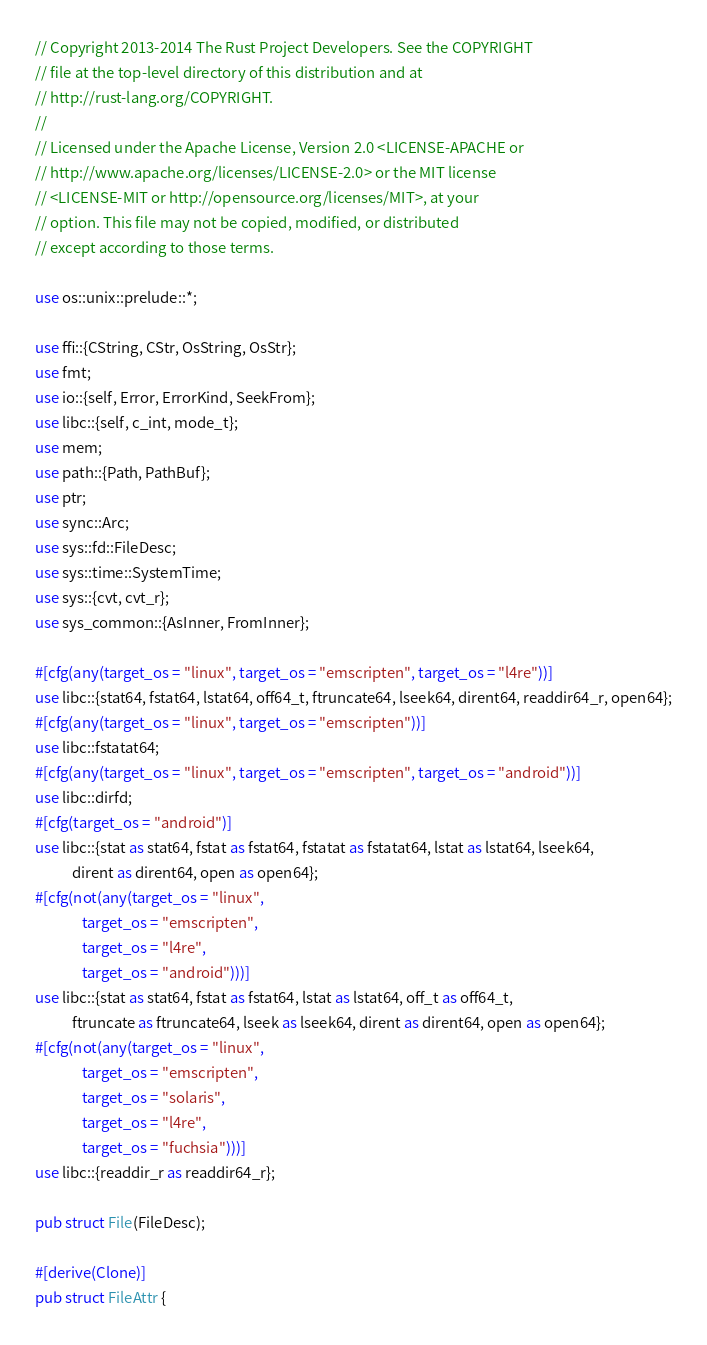<code> <loc_0><loc_0><loc_500><loc_500><_Rust_>// Copyright 2013-2014 The Rust Project Developers. See the COPYRIGHT
// file at the top-level directory of this distribution and at
// http://rust-lang.org/COPYRIGHT.
//
// Licensed under the Apache License, Version 2.0 <LICENSE-APACHE or
// http://www.apache.org/licenses/LICENSE-2.0> or the MIT license
// <LICENSE-MIT or http://opensource.org/licenses/MIT>, at your
// option. This file may not be copied, modified, or distributed
// except according to those terms.

use os::unix::prelude::*;

use ffi::{CString, CStr, OsString, OsStr};
use fmt;
use io::{self, Error, ErrorKind, SeekFrom};
use libc::{self, c_int, mode_t};
use mem;
use path::{Path, PathBuf};
use ptr;
use sync::Arc;
use sys::fd::FileDesc;
use sys::time::SystemTime;
use sys::{cvt, cvt_r};
use sys_common::{AsInner, FromInner};

#[cfg(any(target_os = "linux", target_os = "emscripten", target_os = "l4re"))]
use libc::{stat64, fstat64, lstat64, off64_t, ftruncate64, lseek64, dirent64, readdir64_r, open64};
#[cfg(any(target_os = "linux", target_os = "emscripten"))]
use libc::fstatat64;
#[cfg(any(target_os = "linux", target_os = "emscripten", target_os = "android"))]
use libc::dirfd;
#[cfg(target_os = "android")]
use libc::{stat as stat64, fstat as fstat64, fstatat as fstatat64, lstat as lstat64, lseek64,
           dirent as dirent64, open as open64};
#[cfg(not(any(target_os = "linux",
              target_os = "emscripten",
              target_os = "l4re",
              target_os = "android")))]
use libc::{stat as stat64, fstat as fstat64, lstat as lstat64, off_t as off64_t,
           ftruncate as ftruncate64, lseek as lseek64, dirent as dirent64, open as open64};
#[cfg(not(any(target_os = "linux",
              target_os = "emscripten",
              target_os = "solaris",
              target_os = "l4re",
              target_os = "fuchsia")))]
use libc::{readdir_r as readdir64_r};

pub struct File(FileDesc);

#[derive(Clone)]
pub struct FileAttr {</code> 